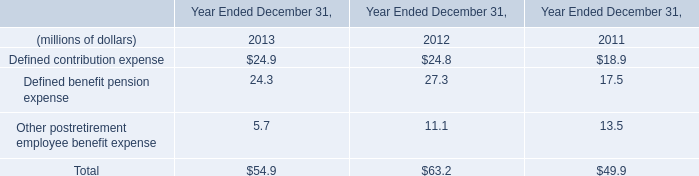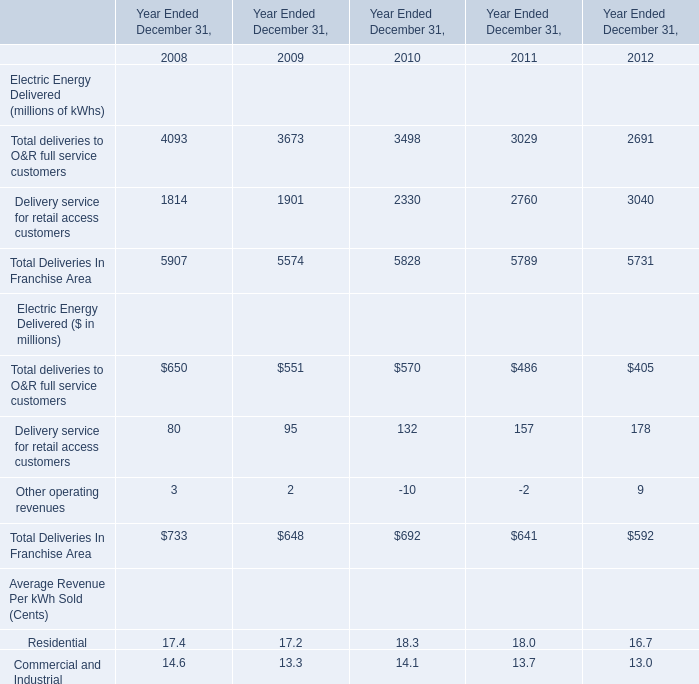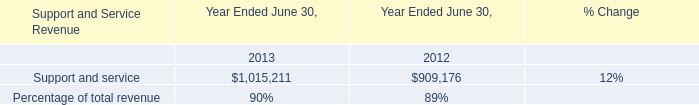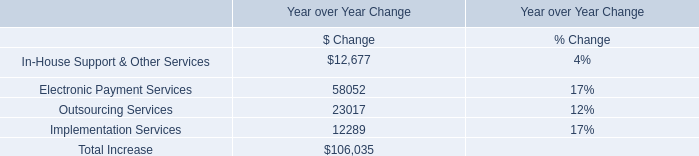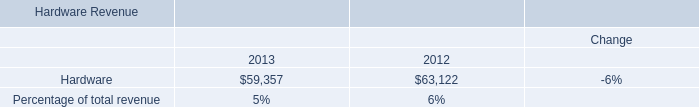Which Electric Energy Delivered continue to rise each year from 2008 to 2012? 
Answer: Delivery service for retail access customers. 